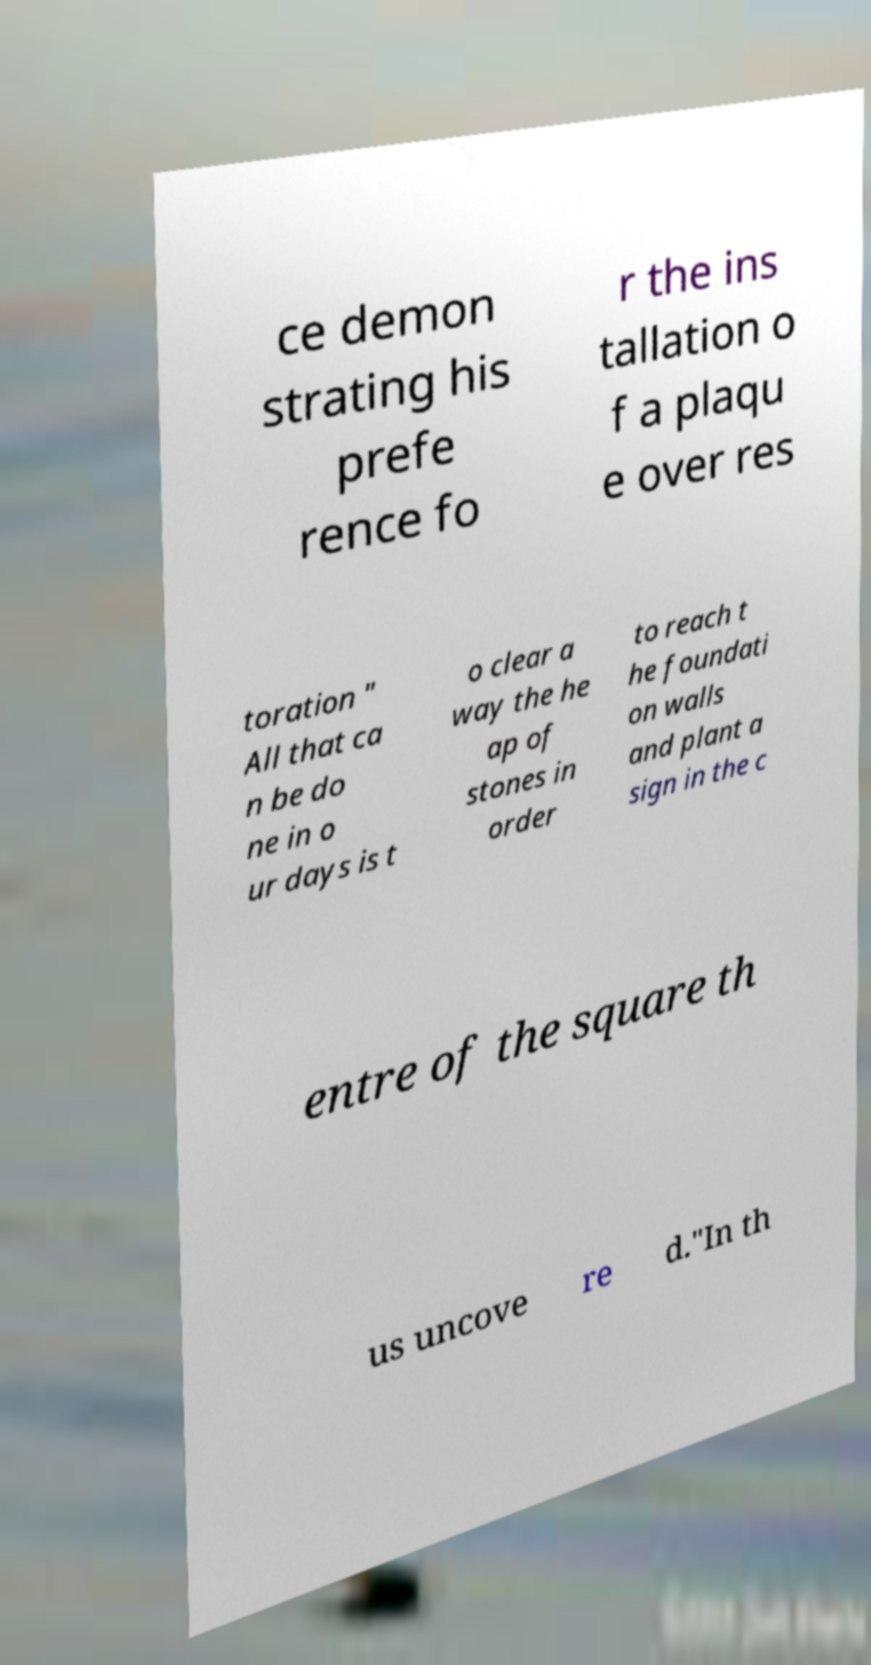Can you read and provide the text displayed in the image?This photo seems to have some interesting text. Can you extract and type it out for me? ce demon strating his prefe rence fo r the ins tallation o f a plaqu e over res toration " All that ca n be do ne in o ur days is t o clear a way the he ap of stones in order to reach t he foundati on walls and plant a sign in the c entre of the square th us uncove re d."In th 